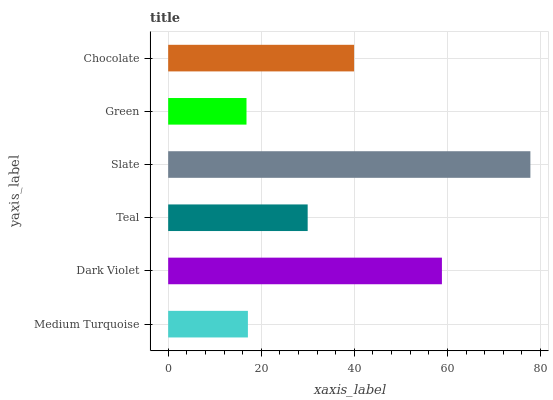Is Green the minimum?
Answer yes or no. Yes. Is Slate the maximum?
Answer yes or no. Yes. Is Dark Violet the minimum?
Answer yes or no. No. Is Dark Violet the maximum?
Answer yes or no. No. Is Dark Violet greater than Medium Turquoise?
Answer yes or no. Yes. Is Medium Turquoise less than Dark Violet?
Answer yes or no. Yes. Is Medium Turquoise greater than Dark Violet?
Answer yes or no. No. Is Dark Violet less than Medium Turquoise?
Answer yes or no. No. Is Chocolate the high median?
Answer yes or no. Yes. Is Teal the low median?
Answer yes or no. Yes. Is Medium Turquoise the high median?
Answer yes or no. No. Is Dark Violet the low median?
Answer yes or no. No. 